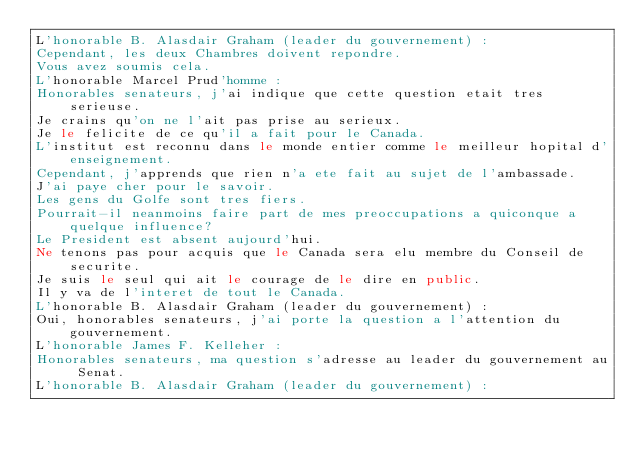<code> <loc_0><loc_0><loc_500><loc_500><_FORTRAN_>L'honorable B. Alasdair Graham (leader du gouvernement) :
Cependant, les deux Chambres doivent repondre. 
Vous avez soumis cela. 
L'honorable Marcel Prud'homme :
Honorables senateurs, j'ai indique que cette question etait tres serieuse. 
Je crains qu'on ne l'ait pas prise au serieux. 
Je le felicite de ce qu'il a fait pour le Canada. 
L'institut est reconnu dans le monde entier comme le meilleur hopital d'enseignement. 
Cependant, j'apprends que rien n'a ete fait au sujet de l'ambassade.  
J'ai paye cher pour le savoir. 
Les gens du Golfe sont tres fiers. 
Pourrait-il neanmoins faire part de mes preoccupations a quiconque a quelque influence?  
Le President est absent aujourd'hui. 
Ne tenons pas pour acquis que le Canada sera elu membre du Conseil de securite. 
Je suis le seul qui ait le courage de le dire en public. 
Il y va de l'interet de tout le Canada.  
L'honorable B. Alasdair Graham (leader du gouvernement) :
Oui, honorables senateurs, j'ai porte la question a l'attention du gouvernement. 
L'honorable James F. Kelleher :
Honorables senateurs, ma question s'adresse au leader du gouvernement au Senat. 
L'honorable B. Alasdair Graham (leader du gouvernement) :</code> 